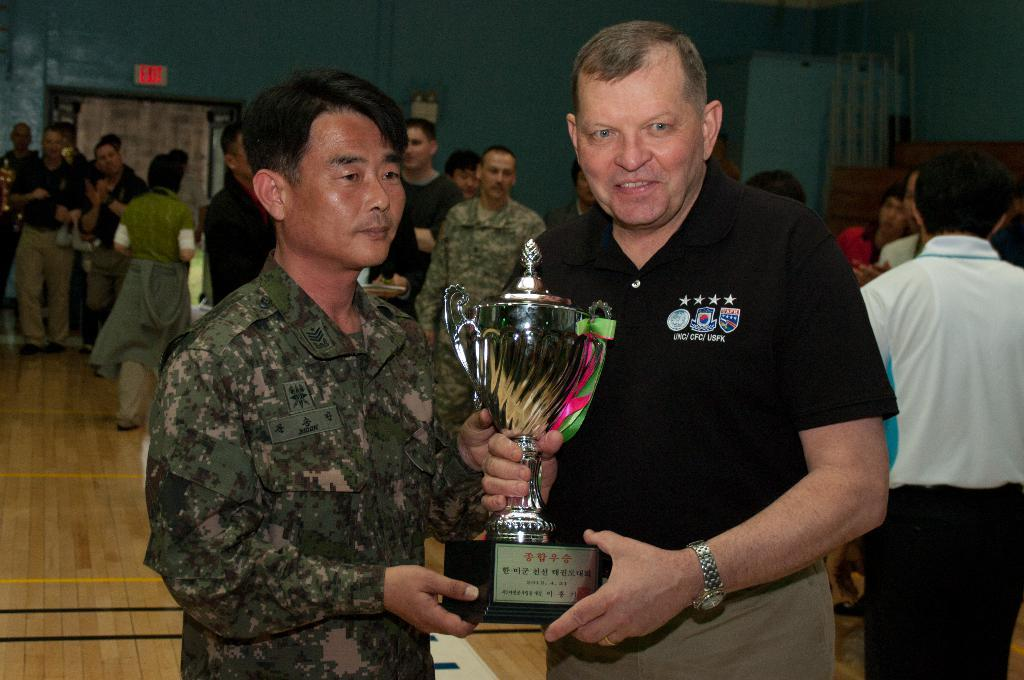What are the two persons in the image holding? The two persons in the image are holding a trophy. What can be seen in the background of the image? There is a group of people and a wall in the background of the image. Can you describe the objects present in the image? Unfortunately, the facts provided do not specify the objects present in the image. What type of whip is being used by the mother in the image? There is no mother or whip present in the image. 